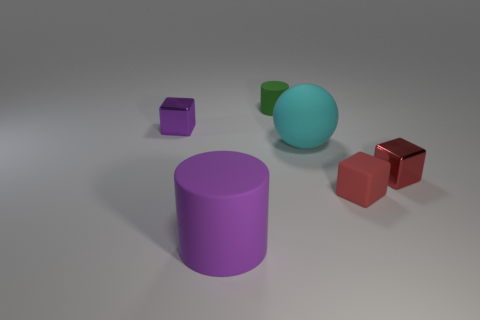There is a large ball; are there any tiny red things in front of it?
Make the answer very short. Yes. There is a rubber thing that is behind the large cyan rubber thing; is its size the same as the shiny cube that is to the left of the tiny cylinder?
Make the answer very short. Yes. Are there any objects that have the same size as the cyan rubber ball?
Ensure brevity in your answer.  Yes. Is the shape of the purple object that is behind the large purple matte cylinder the same as  the small red shiny thing?
Your answer should be compact. Yes. There is a purple object in front of the tiny purple cube; what material is it?
Provide a short and direct response. Rubber. There is a tiny metallic object that is on the left side of the matte cylinder on the left side of the green cylinder; what is its shape?
Ensure brevity in your answer.  Cube. Is the shape of the large cyan object the same as the tiny matte object behind the cyan rubber thing?
Offer a very short reply. No. How many metal objects are to the right of the rubber cube in front of the cyan rubber object?
Your response must be concise. 1. There is a tiny purple thing that is the same shape as the tiny red shiny thing; what material is it?
Your answer should be very brief. Metal. What number of brown objects are either cylinders or small cylinders?
Offer a very short reply. 0. 